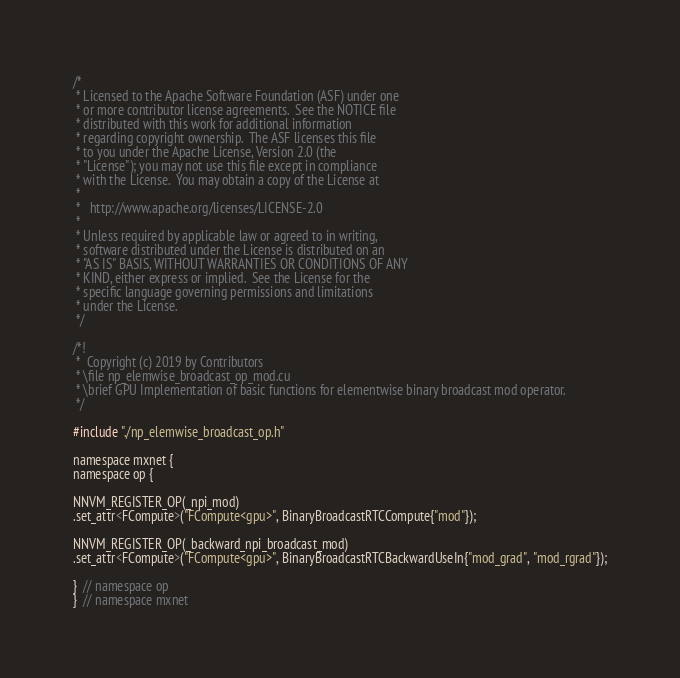Convert code to text. <code><loc_0><loc_0><loc_500><loc_500><_Cuda_>/*
 * Licensed to the Apache Software Foundation (ASF) under one
 * or more contributor license agreements.  See the NOTICE file
 * distributed with this work for additional information
 * regarding copyright ownership.  The ASF licenses this file
 * to you under the Apache License, Version 2.0 (the
 * "License"); you may not use this file except in compliance
 * with the License.  You may obtain a copy of the License at
 *
 *   http://www.apache.org/licenses/LICENSE-2.0
 *
 * Unless required by applicable law or agreed to in writing,
 * software distributed under the License is distributed on an
 * "AS IS" BASIS, WITHOUT WARRANTIES OR CONDITIONS OF ANY
 * KIND, either express or implied.  See the License for the
 * specific language governing permissions and limitations
 * under the License.
 */

/*!
 *  Copyright (c) 2019 by Contributors
 * \file np_elemwise_broadcast_op_mod.cu
 * \brief GPU Implementation of basic functions for elementwise binary broadcast mod operator.
 */

#include "./np_elemwise_broadcast_op.h"

namespace mxnet {
namespace op {

NNVM_REGISTER_OP(_npi_mod)
.set_attr<FCompute>("FCompute<gpu>", BinaryBroadcastRTCCompute{"mod"});

NNVM_REGISTER_OP(_backward_npi_broadcast_mod)
.set_attr<FCompute>("FCompute<gpu>", BinaryBroadcastRTCBackwardUseIn{"mod_grad", "mod_rgrad"});

}  // namespace op
}  // namespace mxnet
</code> 